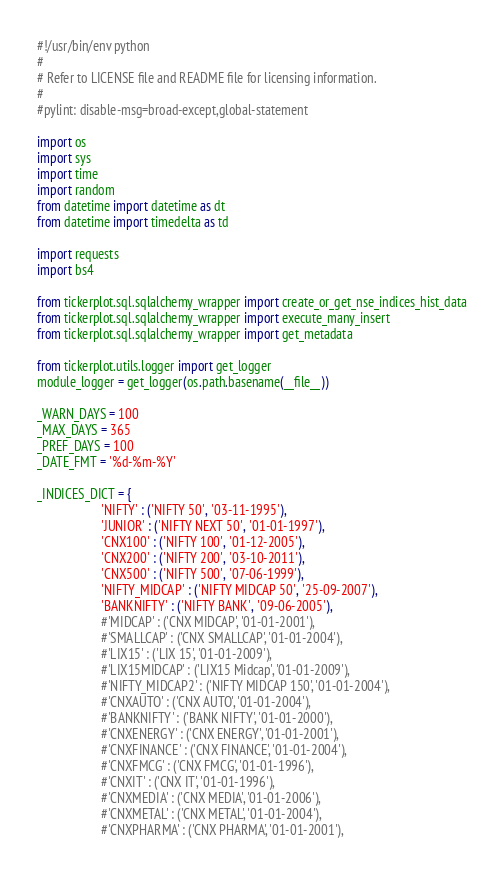Convert code to text. <code><loc_0><loc_0><loc_500><loc_500><_Python_>#!/usr/bin/env python
#
# Refer to LICENSE file and README file for licensing information.
#
#pylint: disable-msg=broad-except,global-statement

import os
import sys
import time
import random
from datetime import datetime as dt
from datetime import timedelta as td

import requests
import bs4

from tickerplot.sql.sqlalchemy_wrapper import create_or_get_nse_indices_hist_data
from tickerplot.sql.sqlalchemy_wrapper import execute_many_insert
from tickerplot.sql.sqlalchemy_wrapper import get_metadata

from tickerplot.utils.logger import get_logger
module_logger = get_logger(os.path.basename(__file__))

_WARN_DAYS = 100
_MAX_DAYS = 365
_PREF_DAYS = 100
_DATE_FMT = '%d-%m-%Y'

_INDICES_DICT = {
                    'NIFTY' : ('NIFTY 50', '03-11-1995'),
                    'JUNIOR' : ('NIFTY NEXT 50', '01-01-1997'),
                    'CNX100' : ('NIFTY 100', '01-12-2005'),
                    'CNX200' : ('NIFTY 200', '03-10-2011'),
                    'CNX500' : ('NIFTY 500', '07-06-1999'),
                    'NIFTY_MIDCAP' : ('NIFTY MIDCAP 50', '25-09-2007'),
                    'BANKNIFTY' : ('NIFTY BANK', '09-06-2005'),
                    #'MIDCAP' : ('CNX MIDCAP', '01-01-2001'),
                    #'SMALLCAP' : ('CNX SMALLCAP', '01-01-2004'),
                    #'LIX15' : ('LIX 15', '01-01-2009'),
                    #'LIX15MIDCAP' : ('LIX15 Midcap', '01-01-2009'),
                    #'NIFTY_MIDCAP2' : ('NIFTY MIDCAP 150', '01-01-2004'),
                    #'CNXAUTO' : ('CNX AUTO', '01-01-2004'),
                    #'BANKNIFTY' : ('BANK NIFTY', '01-01-2000'),
                    #'CNXENERGY' : ('CNX ENERGY', '01-01-2001'),
                    #'CNXFINANCE' : ('CNX FINANCE', '01-01-2004'),
                    #'CNXFMCG' : ('CNX FMCG', '01-01-1996'),
                    #'CNXIT' : ('CNX IT', '01-01-1996'),
                    #'CNXMEDIA' : ('CNX MEDIA', '01-01-2006'),
                    #'CNXMETAL' : ('CNX METAL', '01-01-2004'),
                    #'CNXPHARMA' : ('CNX PHARMA', '01-01-2001'),</code> 